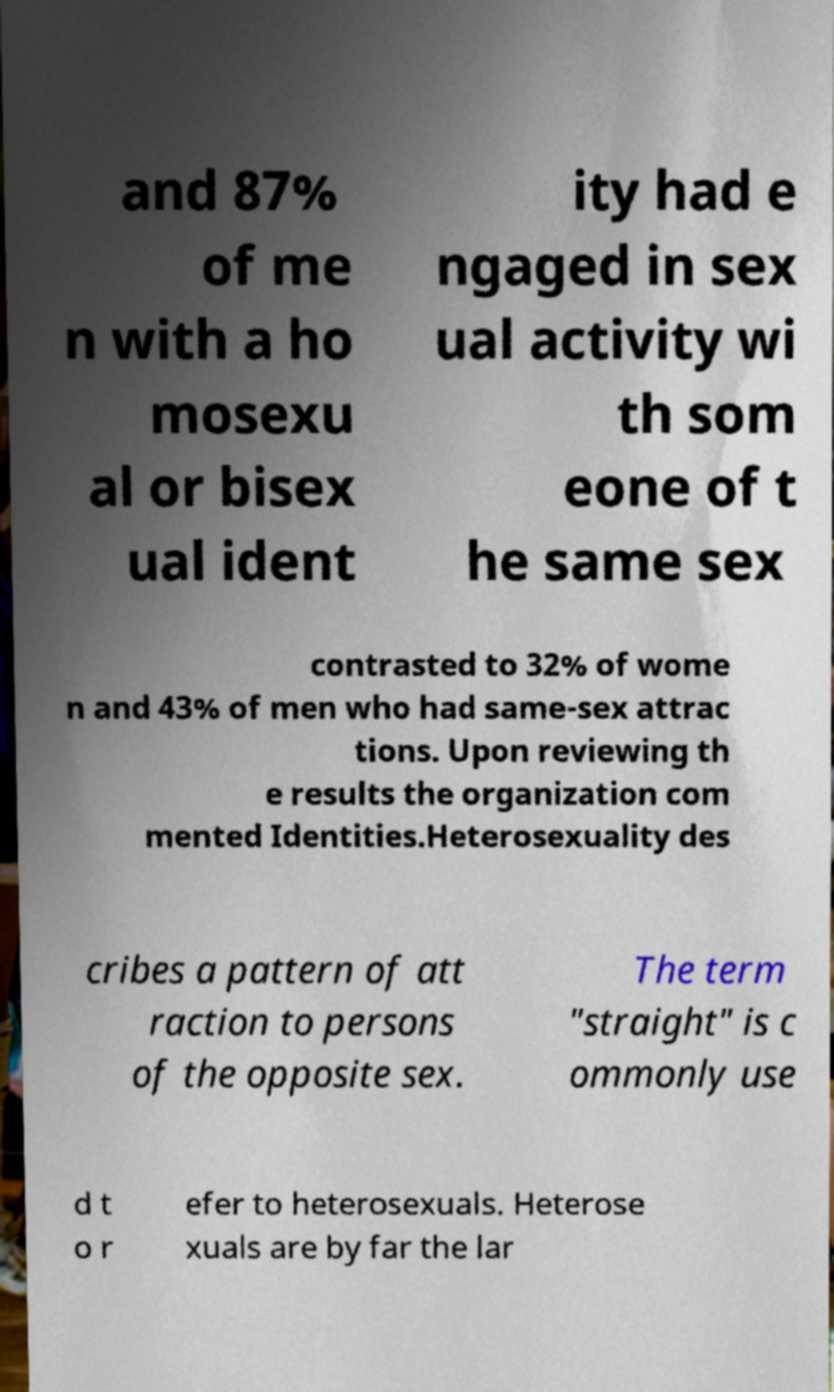Can you read and provide the text displayed in the image?This photo seems to have some interesting text. Can you extract and type it out for me? and 87% of me n with a ho mosexu al or bisex ual ident ity had e ngaged in sex ual activity wi th som eone of t he same sex contrasted to 32% of wome n and 43% of men who had same-sex attrac tions. Upon reviewing th e results the organization com mented Identities.Heterosexuality des cribes a pattern of att raction to persons of the opposite sex. The term "straight" is c ommonly use d t o r efer to heterosexuals. Heterose xuals are by far the lar 